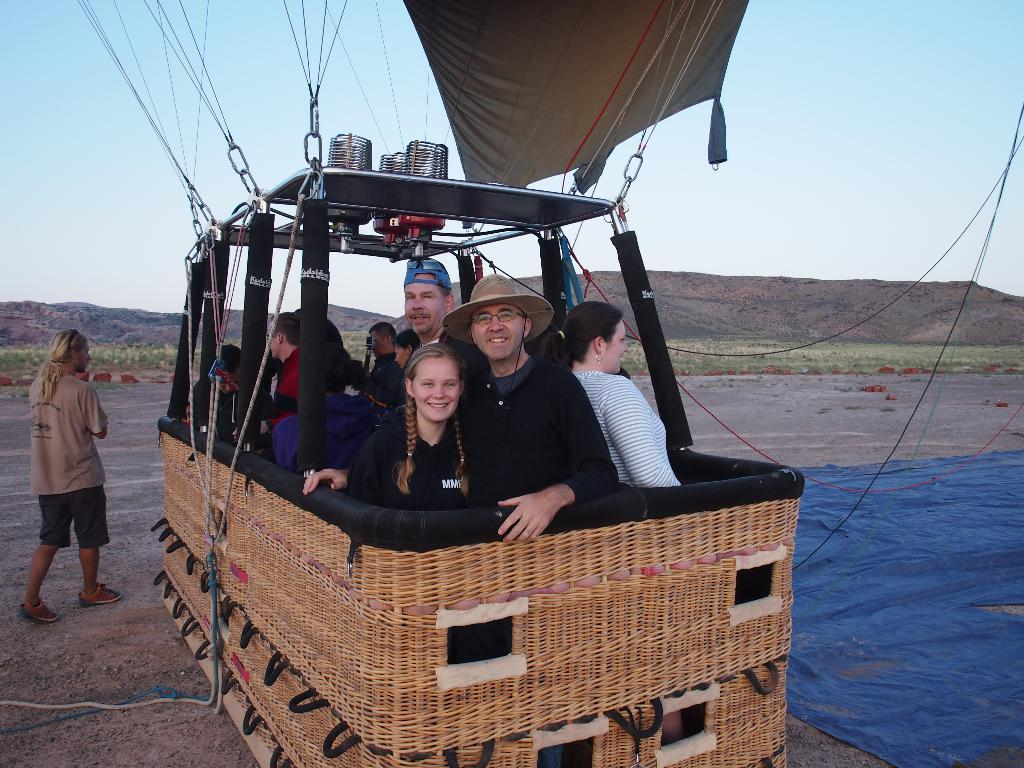What activity are the people in the image participating in? The people in the image are on an air balloon ride. What is the man in the image doing? There is a man walking in the image. What objects are present that are used for attaching or securing? There are hooks with ropes in the image. What type of terrain can be seen in the background? There is grass and hills visible in the background. What part of the natural environment is visible in the image? The sky is visible in the background. What type of sheet is being used to make the observation in the image? There is no sheet present in the image, nor is there any indication of an observation being made. 